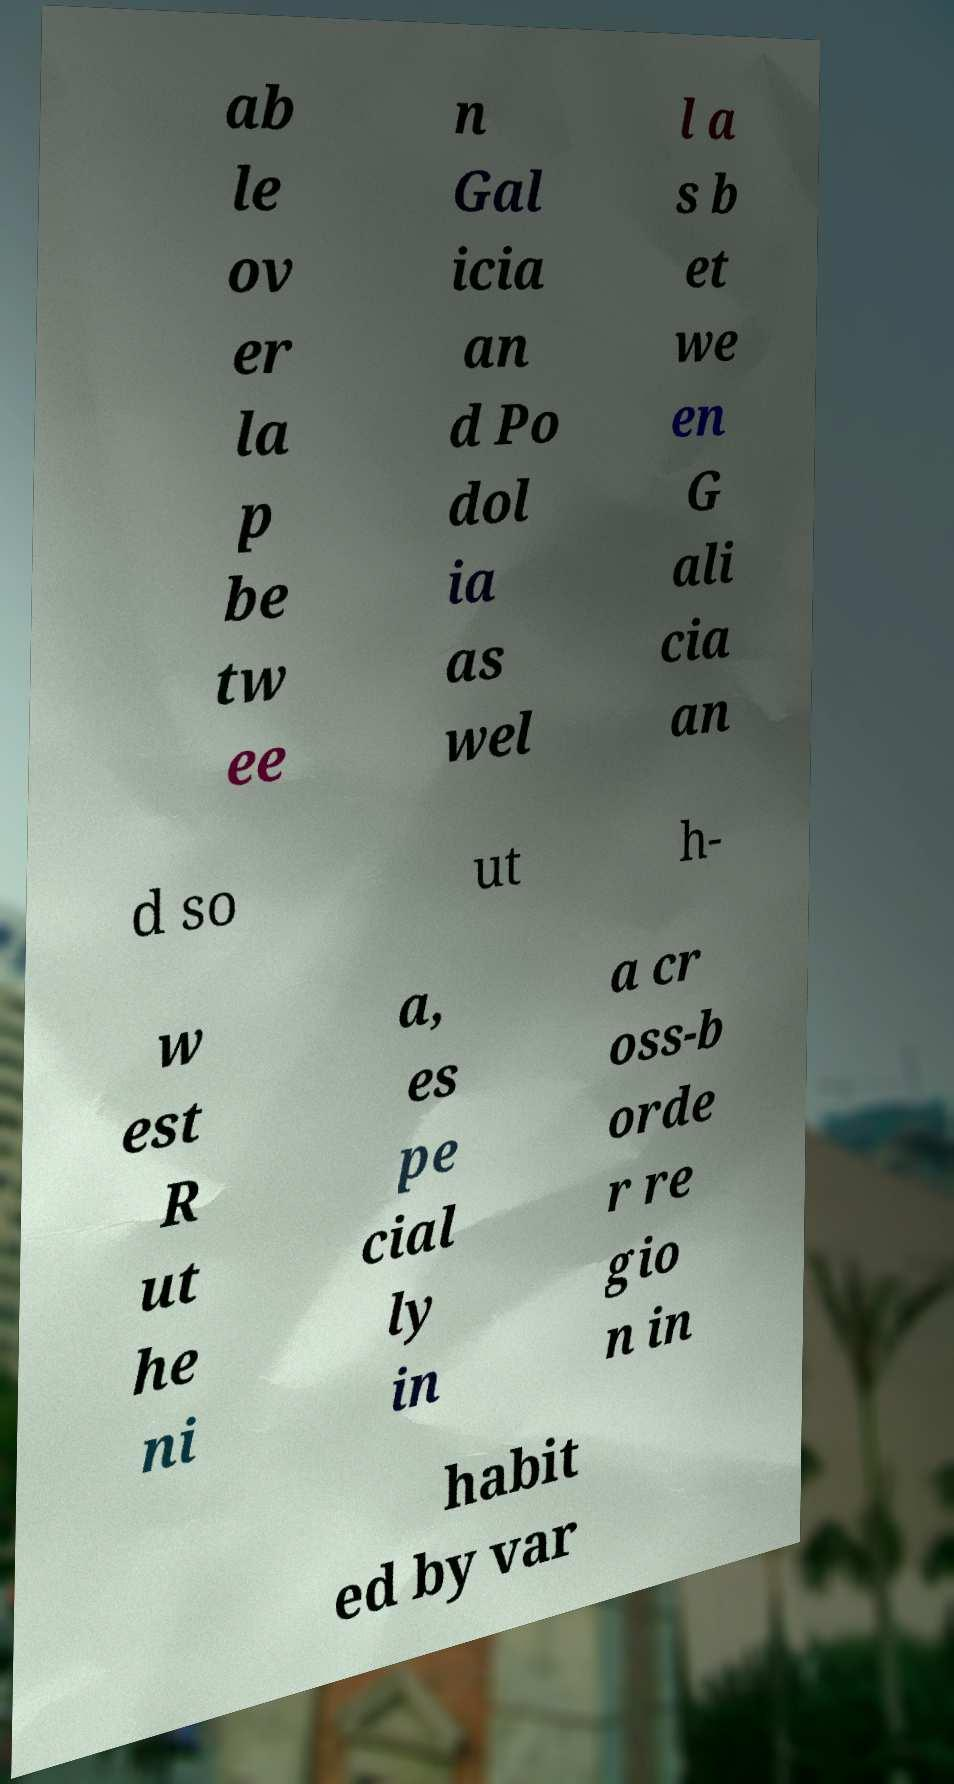What messages or text are displayed in this image? I need them in a readable, typed format. ab le ov er la p be tw ee n Gal icia an d Po dol ia as wel l a s b et we en G ali cia an d so ut h- w est R ut he ni a, es pe cial ly in a cr oss-b orde r re gio n in habit ed by var 